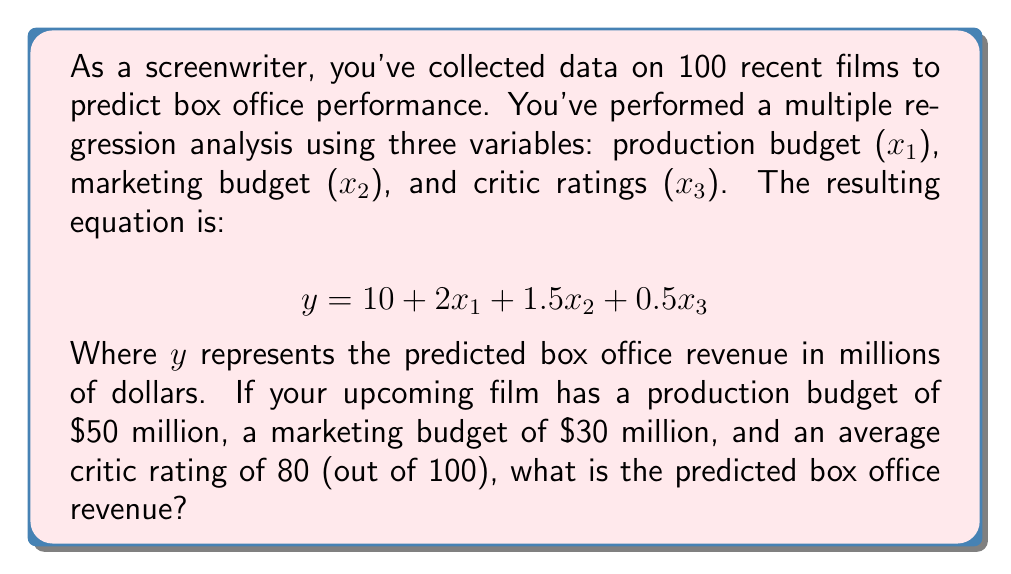Solve this math problem. To solve this problem, we'll follow these steps:

1. Identify the given values:
   x₁ (production budget) = $50 million
   x₂ (marketing budget) = $30 million
   x₃ (critic ratings) = 80

2. Substitute these values into the regression equation:
   $$y = 10 + 2x₁ + 1.5x₂ + 0.5x₃$$

3. Calculate each term:
   Constant term: 10
   Production budget term: $2 \times 50 = 100$
   Marketing budget term: $1.5 \times 30 = 45$
   Critic ratings term: $0.5 \times 80 = 40$

4. Sum up all the terms:
   $$y = 10 + 100 + 45 + 40 = 195$$

Therefore, the predicted box office revenue for your upcoming film is $195 million.
Answer: $195 million 